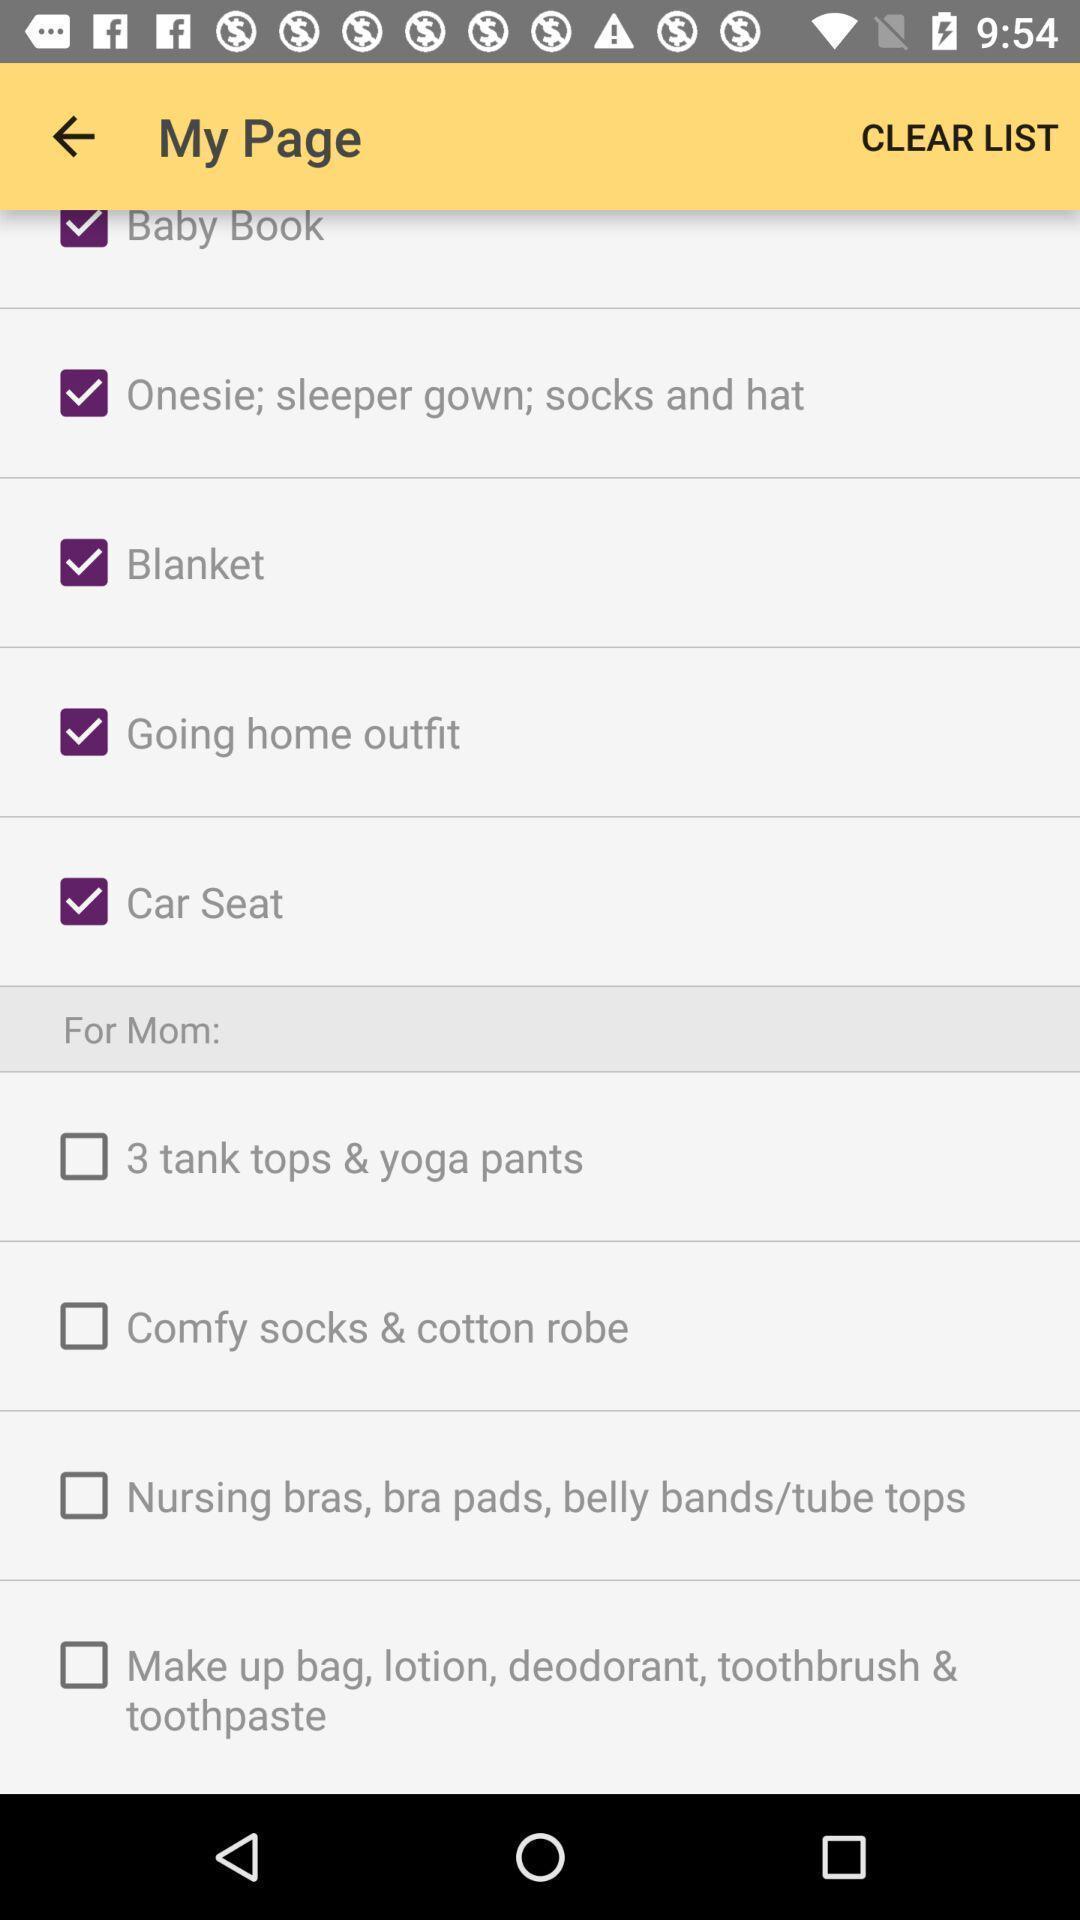Provide a description of this screenshot. Screen showing list of various categories of a shopping app. 